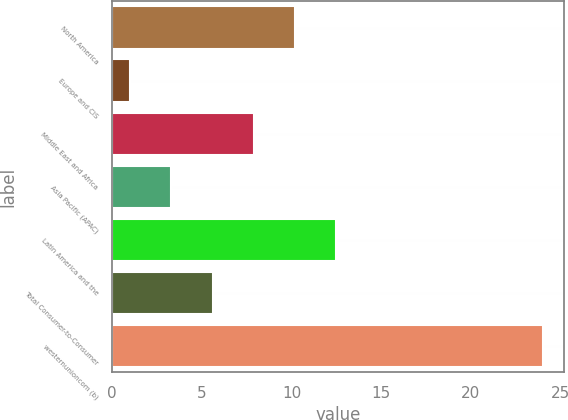<chart> <loc_0><loc_0><loc_500><loc_500><bar_chart><fcel>North America<fcel>Europe and CIS<fcel>Middle East and Africa<fcel>Asia Pacific (APAC)<fcel>Latin America and the<fcel>Total Consumer-to-Consumer<fcel>westernunioncom (b)<nl><fcel>10.2<fcel>1<fcel>7.9<fcel>3.3<fcel>12.5<fcel>5.6<fcel>24<nl></chart> 